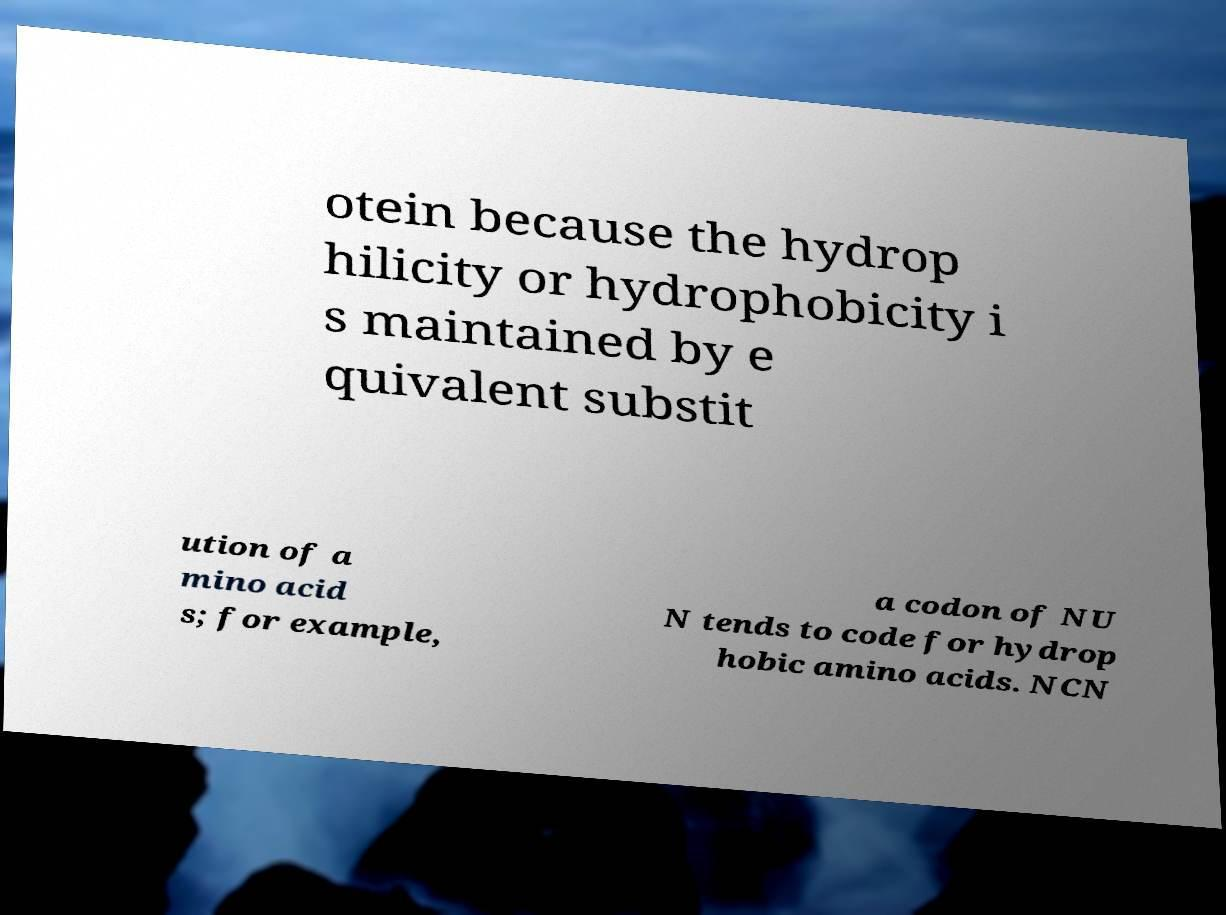Please read and relay the text visible in this image. What does it say? otein because the hydrop hilicity or hydrophobicity i s maintained by e quivalent substit ution of a mino acid s; for example, a codon of NU N tends to code for hydrop hobic amino acids. NCN 